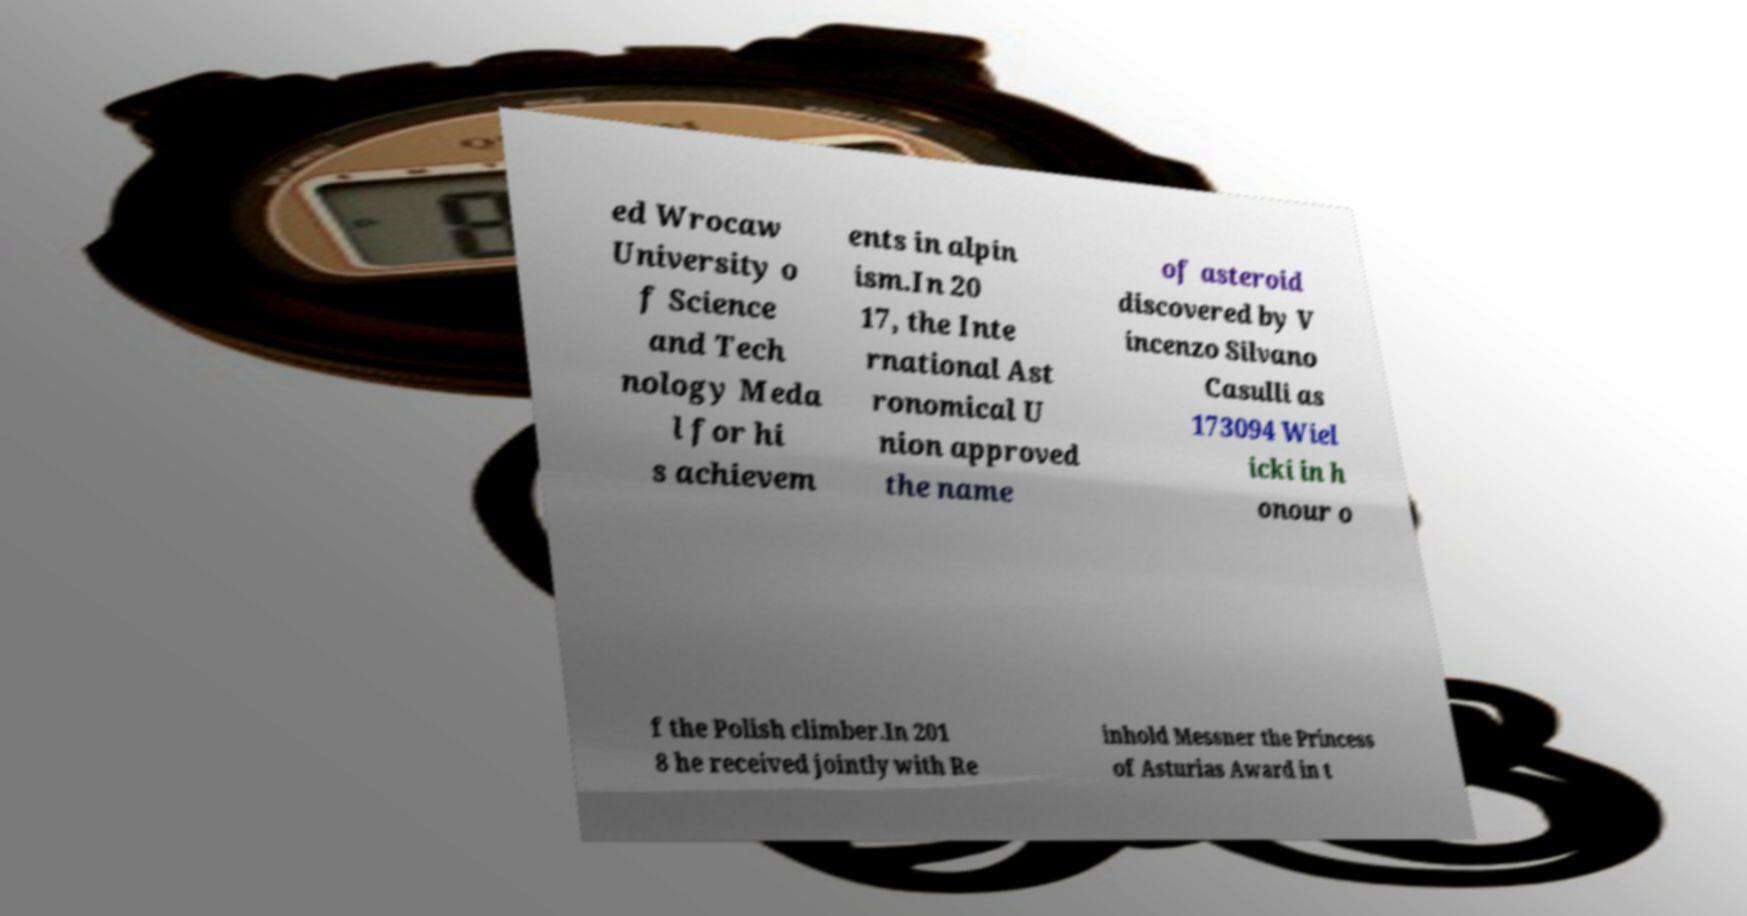What messages or text are displayed in this image? I need them in a readable, typed format. ed Wrocaw University o f Science and Tech nology Meda l for hi s achievem ents in alpin ism.In 20 17, the Inte rnational Ast ronomical U nion approved the name of asteroid discovered by V incenzo Silvano Casulli as 173094 Wiel icki in h onour o f the Polish climber.In 201 8 he received jointly with Re inhold Messner the Princess of Asturias Award in t 